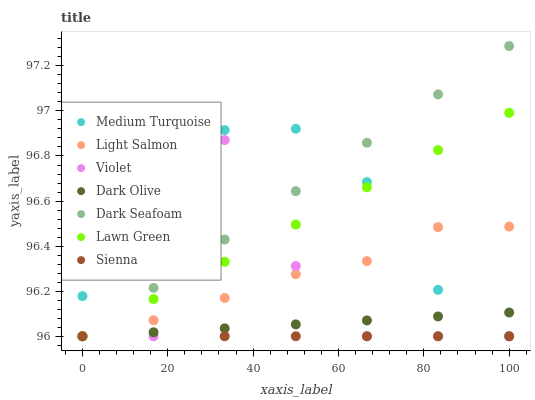Does Dark Olive have the minimum area under the curve?
Answer yes or no. Yes. Does Dark Seafoam have the maximum area under the curve?
Answer yes or no. Yes. Does Light Salmon have the minimum area under the curve?
Answer yes or no. No. Does Light Salmon have the maximum area under the curve?
Answer yes or no. No. Is Dark Olive the smoothest?
Answer yes or no. Yes. Is Violet the roughest?
Answer yes or no. Yes. Is Light Salmon the smoothest?
Answer yes or no. No. Is Light Salmon the roughest?
Answer yes or no. No. Does Lawn Green have the lowest value?
Answer yes or no. Yes. Does Dark Seafoam have the highest value?
Answer yes or no. Yes. Does Light Salmon have the highest value?
Answer yes or no. No. Does Medium Turquoise intersect Dark Seafoam?
Answer yes or no. Yes. Is Medium Turquoise less than Dark Seafoam?
Answer yes or no. No. Is Medium Turquoise greater than Dark Seafoam?
Answer yes or no. No. 